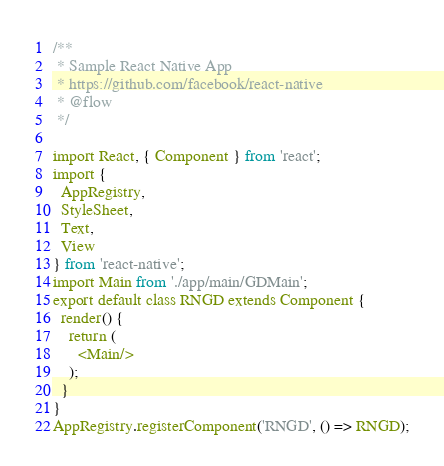Convert code to text. <code><loc_0><loc_0><loc_500><loc_500><_JavaScript_>/**
 * Sample React Native App
 * https://github.com/facebook/react-native
 * @flow
 */

import React, { Component } from 'react';
import {
  AppRegistry,
  StyleSheet,
  Text,
  View
} from 'react-native';
import Main from './app/main/GDMain';
export default class RNGD extends Component {
  render() {
    return (
      <Main/>
    );
  }
}
AppRegistry.registerComponent('RNGD', () => RNGD);
</code> 